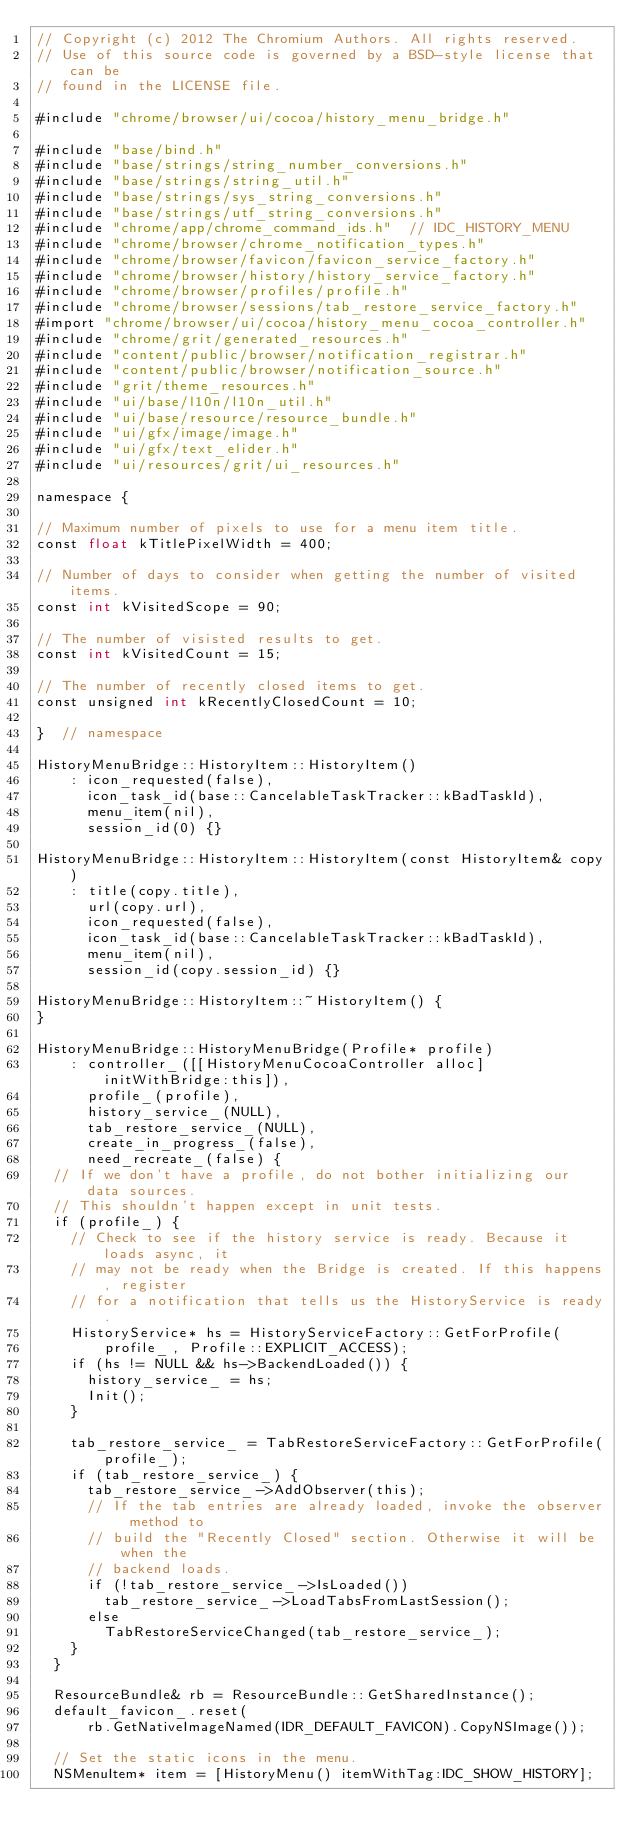<code> <loc_0><loc_0><loc_500><loc_500><_ObjectiveC_>// Copyright (c) 2012 The Chromium Authors. All rights reserved.
// Use of this source code is governed by a BSD-style license that can be
// found in the LICENSE file.

#include "chrome/browser/ui/cocoa/history_menu_bridge.h"

#include "base/bind.h"
#include "base/strings/string_number_conversions.h"
#include "base/strings/string_util.h"
#include "base/strings/sys_string_conversions.h"
#include "base/strings/utf_string_conversions.h"
#include "chrome/app/chrome_command_ids.h"  // IDC_HISTORY_MENU
#include "chrome/browser/chrome_notification_types.h"
#include "chrome/browser/favicon/favicon_service_factory.h"
#include "chrome/browser/history/history_service_factory.h"
#include "chrome/browser/profiles/profile.h"
#include "chrome/browser/sessions/tab_restore_service_factory.h"
#import "chrome/browser/ui/cocoa/history_menu_cocoa_controller.h"
#include "chrome/grit/generated_resources.h"
#include "content/public/browser/notification_registrar.h"
#include "content/public/browser/notification_source.h"
#include "grit/theme_resources.h"
#include "ui/base/l10n/l10n_util.h"
#include "ui/base/resource/resource_bundle.h"
#include "ui/gfx/image/image.h"
#include "ui/gfx/text_elider.h"
#include "ui/resources/grit/ui_resources.h"

namespace {

// Maximum number of pixels to use for a menu item title.
const float kTitlePixelWidth = 400;

// Number of days to consider when getting the number of visited items.
const int kVisitedScope = 90;

// The number of visisted results to get.
const int kVisitedCount = 15;

// The number of recently closed items to get.
const unsigned int kRecentlyClosedCount = 10;

}  // namespace

HistoryMenuBridge::HistoryItem::HistoryItem()
    : icon_requested(false),
      icon_task_id(base::CancelableTaskTracker::kBadTaskId),
      menu_item(nil),
      session_id(0) {}

HistoryMenuBridge::HistoryItem::HistoryItem(const HistoryItem& copy)
    : title(copy.title),
      url(copy.url),
      icon_requested(false),
      icon_task_id(base::CancelableTaskTracker::kBadTaskId),
      menu_item(nil),
      session_id(copy.session_id) {}

HistoryMenuBridge::HistoryItem::~HistoryItem() {
}

HistoryMenuBridge::HistoryMenuBridge(Profile* profile)
    : controller_([[HistoryMenuCocoaController alloc] initWithBridge:this]),
      profile_(profile),
      history_service_(NULL),
      tab_restore_service_(NULL),
      create_in_progress_(false),
      need_recreate_(false) {
  // If we don't have a profile, do not bother initializing our data sources.
  // This shouldn't happen except in unit tests.
  if (profile_) {
    // Check to see if the history service is ready. Because it loads async, it
    // may not be ready when the Bridge is created. If this happens, register
    // for a notification that tells us the HistoryService is ready.
    HistoryService* hs = HistoryServiceFactory::GetForProfile(
        profile_, Profile::EXPLICIT_ACCESS);
    if (hs != NULL && hs->BackendLoaded()) {
      history_service_ = hs;
      Init();
    }

    tab_restore_service_ = TabRestoreServiceFactory::GetForProfile(profile_);
    if (tab_restore_service_) {
      tab_restore_service_->AddObserver(this);
      // If the tab entries are already loaded, invoke the observer method to
      // build the "Recently Closed" section. Otherwise it will be when the
      // backend loads.
      if (!tab_restore_service_->IsLoaded())
        tab_restore_service_->LoadTabsFromLastSession();
      else
        TabRestoreServiceChanged(tab_restore_service_);
    }
  }

  ResourceBundle& rb = ResourceBundle::GetSharedInstance();
  default_favicon_.reset(
      rb.GetNativeImageNamed(IDR_DEFAULT_FAVICON).CopyNSImage());

  // Set the static icons in the menu.
  NSMenuItem* item = [HistoryMenu() itemWithTag:IDC_SHOW_HISTORY];</code> 